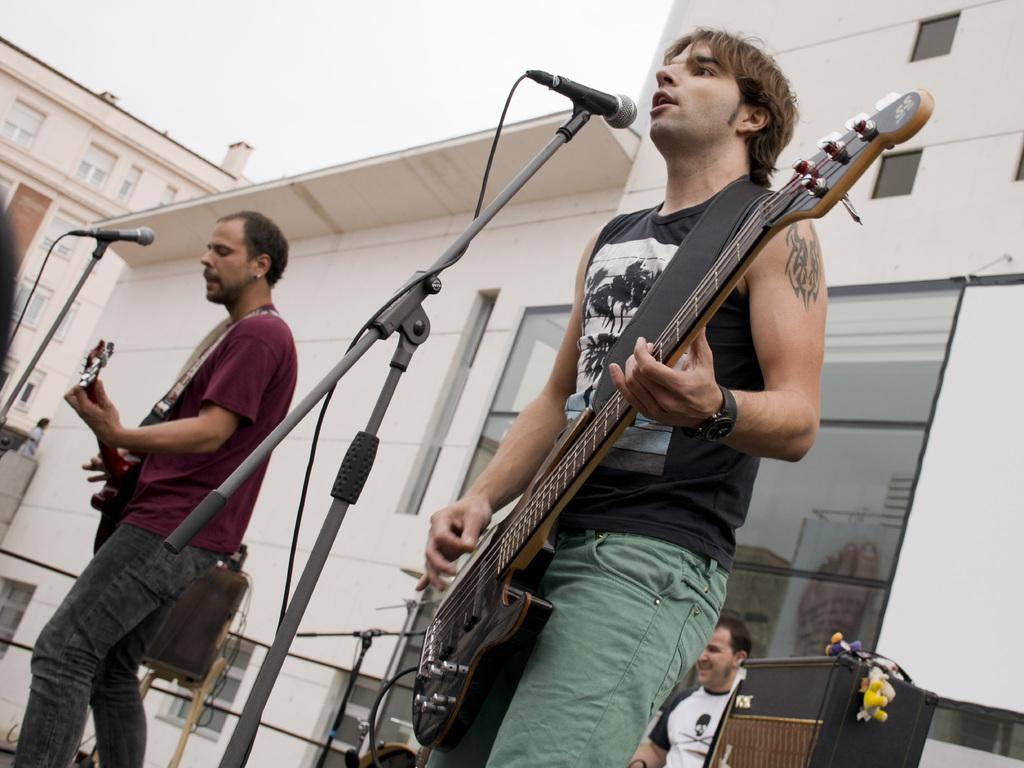What are the two persons in the image doing? The two persons in the image are playing guitar and singing. Can you describe the position of one of the persons? One of the persons is in front of a microphone. What is the third person in the image doing? The third person in the image is playing drums. What can be seen in the background of the image? There is a building visible in the background of the image. What type of lead is the person holding while playing the guitar in the image? There is no lead visible in the image, as the person is playing the guitar without any visible cables or connections. 